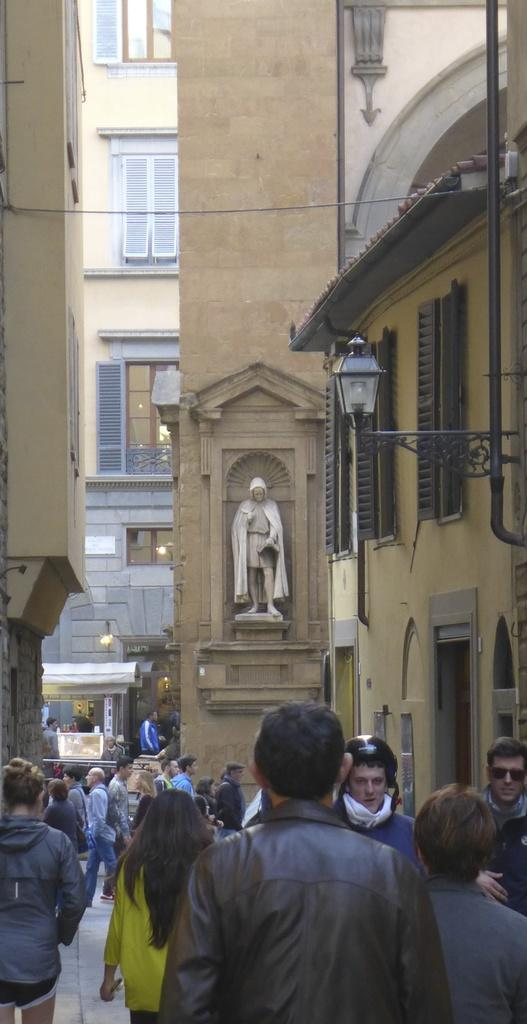What are the people in the image doing? The people in the image are walking on the road. What can be seen in the background of the image? There are buildings visible in the image. Can you describe the sculpture in the image? There is a big pillar with a sculpture of persons in the image. How many giraffes are walking with the people in the image? There are no giraffes present in the image; it only features people walking on the road. 